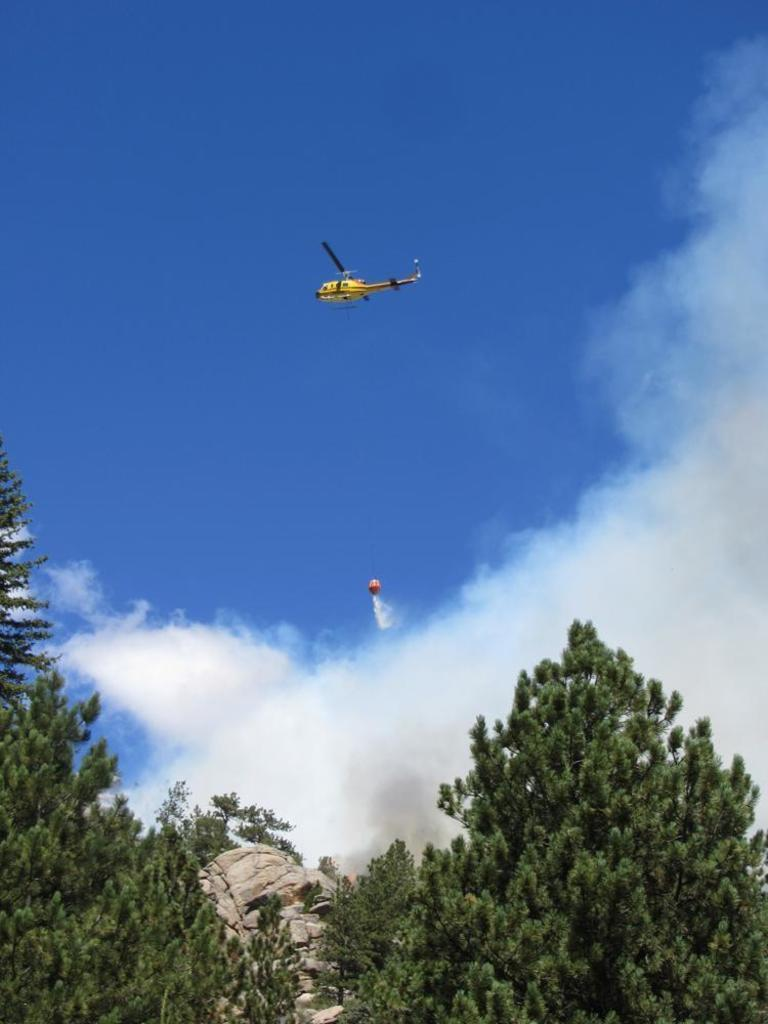What type of vehicle is present in the image? There is a helicopter in the image. What other flying object is present in the image? There is a balloon in the image. Where are the helicopter and balloon located in the image? Both the helicopter and the balloon are flying in the sky. What can be seen in the sky besides the helicopter and balloon? Clouds are visible in the sky. What type of vegetation is present in the image? There are trees in the image. What non-living object is present in the image? There is a rock in the image. What color is the silver wheel on the helicopter in the image? There is no silver wheel present on the helicopter in the image. 